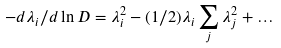<formula> <loc_0><loc_0><loc_500><loc_500>- d \lambda _ { i } / d \ln D = \lambda _ { i } ^ { 2 } - ( 1 / 2 ) \lambda _ { i } \sum _ { j } \lambda _ { j } ^ { 2 } + \dots</formula> 